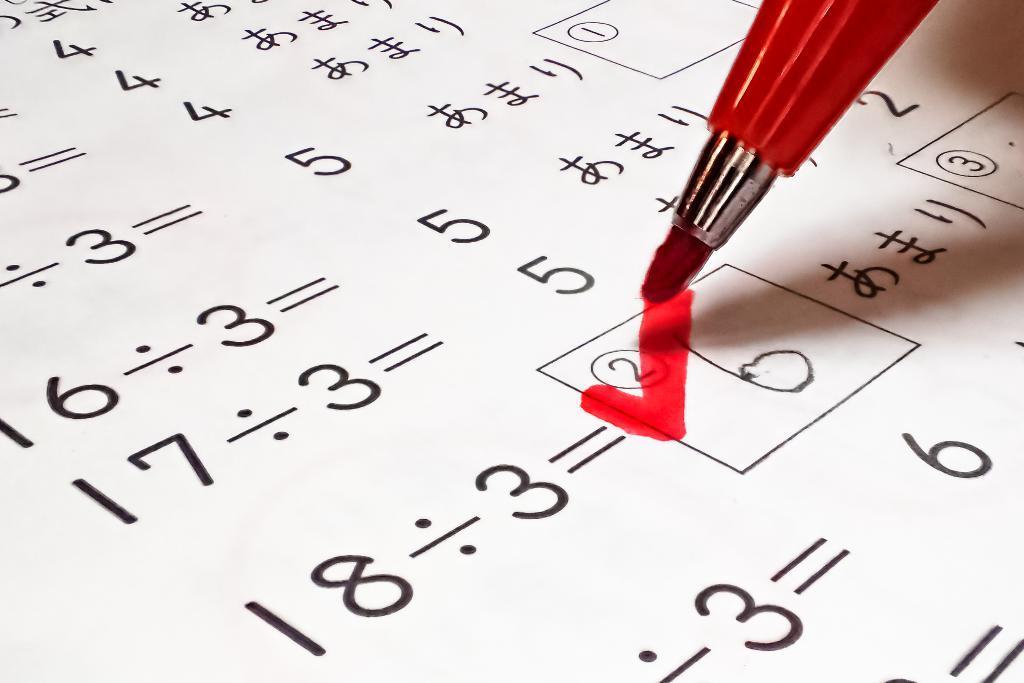Please provide a concise description of this image. In this image I can see a red color marker and white color paper. Something is written on it with a black color. 